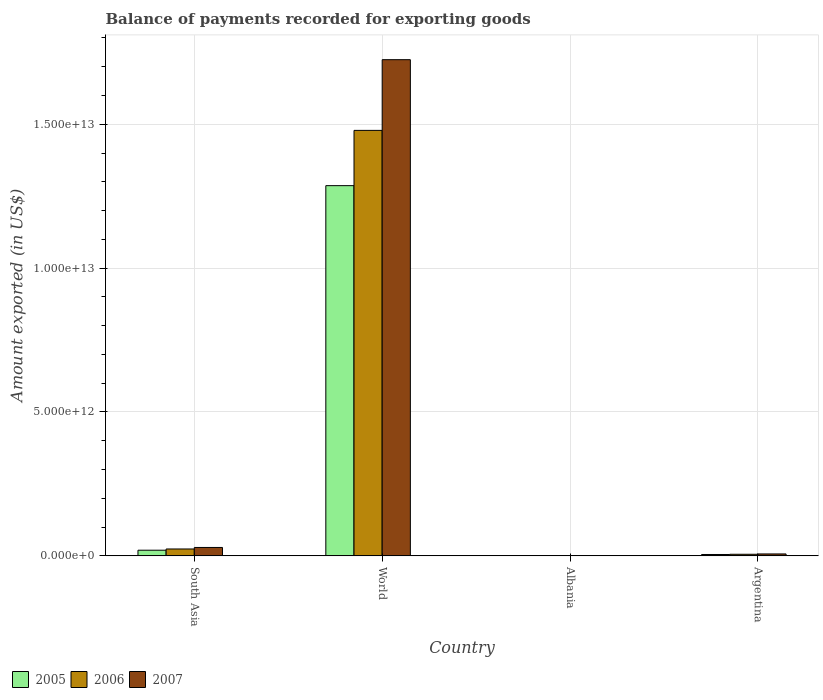How many bars are there on the 1st tick from the right?
Provide a short and direct response. 3. In how many cases, is the number of bars for a given country not equal to the number of legend labels?
Provide a succinct answer. 0. What is the amount exported in 2005 in South Asia?
Provide a short and direct response. 1.95e+11. Across all countries, what is the maximum amount exported in 2005?
Provide a short and direct response. 1.29e+13. Across all countries, what is the minimum amount exported in 2005?
Give a very brief answer. 1.46e+09. In which country was the amount exported in 2007 maximum?
Offer a very short reply. World. In which country was the amount exported in 2005 minimum?
Provide a succinct answer. Albania. What is the total amount exported in 2006 in the graph?
Your answer should be compact. 1.51e+13. What is the difference between the amount exported in 2006 in Argentina and that in South Asia?
Offer a terse response. -1.84e+11. What is the difference between the amount exported in 2007 in World and the amount exported in 2006 in Albania?
Make the answer very short. 1.72e+13. What is the average amount exported in 2007 per country?
Your answer should be compact. 4.40e+12. What is the difference between the amount exported of/in 2007 and amount exported of/in 2005 in World?
Offer a very short reply. 4.38e+12. In how many countries, is the amount exported in 2005 greater than 5000000000000 US$?
Keep it short and to the point. 1. What is the ratio of the amount exported in 2007 in South Asia to that in World?
Your answer should be very brief. 0.02. What is the difference between the highest and the second highest amount exported in 2006?
Offer a terse response. -1.47e+13. What is the difference between the highest and the lowest amount exported in 2006?
Provide a short and direct response. 1.48e+13. In how many countries, is the amount exported in 2006 greater than the average amount exported in 2006 taken over all countries?
Your answer should be compact. 1. What does the 1st bar from the right in South Asia represents?
Offer a very short reply. 2007. Is it the case that in every country, the sum of the amount exported in 2007 and amount exported in 2006 is greater than the amount exported in 2005?
Provide a short and direct response. Yes. How many bars are there?
Give a very brief answer. 12. What is the difference between two consecutive major ticks on the Y-axis?
Give a very brief answer. 5.00e+12. Are the values on the major ticks of Y-axis written in scientific E-notation?
Offer a terse response. Yes. Where does the legend appear in the graph?
Provide a short and direct response. Bottom left. How are the legend labels stacked?
Provide a short and direct response. Horizontal. What is the title of the graph?
Your answer should be very brief. Balance of payments recorded for exporting goods. Does "1964" appear as one of the legend labels in the graph?
Keep it short and to the point. No. What is the label or title of the X-axis?
Your answer should be compact. Country. What is the label or title of the Y-axis?
Ensure brevity in your answer.  Amount exported (in US$). What is the Amount exported (in US$) in 2005 in South Asia?
Your response must be concise. 1.95e+11. What is the Amount exported (in US$) in 2006 in South Asia?
Offer a terse response. 2.39e+11. What is the Amount exported (in US$) of 2007 in South Asia?
Offer a terse response. 2.91e+11. What is the Amount exported (in US$) in 2005 in World?
Keep it short and to the point. 1.29e+13. What is the Amount exported (in US$) of 2006 in World?
Provide a short and direct response. 1.48e+13. What is the Amount exported (in US$) in 2007 in World?
Your answer should be very brief. 1.72e+13. What is the Amount exported (in US$) in 2005 in Albania?
Offer a very short reply. 1.46e+09. What is the Amount exported (in US$) in 2006 in Albania?
Your answer should be compact. 1.87e+09. What is the Amount exported (in US$) in 2007 in Albania?
Make the answer very short. 2.46e+09. What is the Amount exported (in US$) in 2005 in Argentina?
Make the answer very short. 4.69e+1. What is the Amount exported (in US$) of 2006 in Argentina?
Keep it short and to the point. 5.44e+1. What is the Amount exported (in US$) in 2007 in Argentina?
Your answer should be very brief. 6.62e+1. Across all countries, what is the maximum Amount exported (in US$) of 2005?
Your answer should be very brief. 1.29e+13. Across all countries, what is the maximum Amount exported (in US$) of 2006?
Keep it short and to the point. 1.48e+13. Across all countries, what is the maximum Amount exported (in US$) of 2007?
Ensure brevity in your answer.  1.72e+13. Across all countries, what is the minimum Amount exported (in US$) in 2005?
Make the answer very short. 1.46e+09. Across all countries, what is the minimum Amount exported (in US$) of 2006?
Keep it short and to the point. 1.87e+09. Across all countries, what is the minimum Amount exported (in US$) of 2007?
Make the answer very short. 2.46e+09. What is the total Amount exported (in US$) of 2005 in the graph?
Your answer should be very brief. 1.31e+13. What is the total Amount exported (in US$) of 2006 in the graph?
Your answer should be compact. 1.51e+13. What is the total Amount exported (in US$) of 2007 in the graph?
Give a very brief answer. 1.76e+13. What is the difference between the Amount exported (in US$) in 2005 in South Asia and that in World?
Keep it short and to the point. -1.27e+13. What is the difference between the Amount exported (in US$) in 2006 in South Asia and that in World?
Provide a short and direct response. -1.46e+13. What is the difference between the Amount exported (in US$) in 2007 in South Asia and that in World?
Your answer should be very brief. -1.70e+13. What is the difference between the Amount exported (in US$) of 2005 in South Asia and that in Albania?
Provide a short and direct response. 1.94e+11. What is the difference between the Amount exported (in US$) in 2006 in South Asia and that in Albania?
Your answer should be compact. 2.37e+11. What is the difference between the Amount exported (in US$) of 2007 in South Asia and that in Albania?
Keep it short and to the point. 2.89e+11. What is the difference between the Amount exported (in US$) of 2005 in South Asia and that in Argentina?
Keep it short and to the point. 1.49e+11. What is the difference between the Amount exported (in US$) in 2006 in South Asia and that in Argentina?
Make the answer very short. 1.84e+11. What is the difference between the Amount exported (in US$) of 2007 in South Asia and that in Argentina?
Your response must be concise. 2.25e+11. What is the difference between the Amount exported (in US$) of 2005 in World and that in Albania?
Your answer should be compact. 1.29e+13. What is the difference between the Amount exported (in US$) in 2006 in World and that in Albania?
Provide a short and direct response. 1.48e+13. What is the difference between the Amount exported (in US$) of 2007 in World and that in Albania?
Give a very brief answer. 1.72e+13. What is the difference between the Amount exported (in US$) in 2005 in World and that in Argentina?
Offer a terse response. 1.28e+13. What is the difference between the Amount exported (in US$) in 2006 in World and that in Argentina?
Your answer should be very brief. 1.47e+13. What is the difference between the Amount exported (in US$) in 2007 in World and that in Argentina?
Give a very brief answer. 1.72e+13. What is the difference between the Amount exported (in US$) of 2005 in Albania and that in Argentina?
Keep it short and to the point. -4.54e+1. What is the difference between the Amount exported (in US$) of 2006 in Albania and that in Argentina?
Your answer should be compact. -5.26e+1. What is the difference between the Amount exported (in US$) in 2007 in Albania and that in Argentina?
Provide a succinct answer. -6.37e+1. What is the difference between the Amount exported (in US$) of 2005 in South Asia and the Amount exported (in US$) of 2006 in World?
Your response must be concise. -1.46e+13. What is the difference between the Amount exported (in US$) of 2005 in South Asia and the Amount exported (in US$) of 2007 in World?
Your response must be concise. -1.71e+13. What is the difference between the Amount exported (in US$) in 2006 in South Asia and the Amount exported (in US$) in 2007 in World?
Offer a very short reply. -1.70e+13. What is the difference between the Amount exported (in US$) in 2005 in South Asia and the Amount exported (in US$) in 2006 in Albania?
Your response must be concise. 1.94e+11. What is the difference between the Amount exported (in US$) in 2005 in South Asia and the Amount exported (in US$) in 2007 in Albania?
Keep it short and to the point. 1.93e+11. What is the difference between the Amount exported (in US$) in 2006 in South Asia and the Amount exported (in US$) in 2007 in Albania?
Your answer should be very brief. 2.36e+11. What is the difference between the Amount exported (in US$) of 2005 in South Asia and the Amount exported (in US$) of 2006 in Argentina?
Your answer should be very brief. 1.41e+11. What is the difference between the Amount exported (in US$) in 2005 in South Asia and the Amount exported (in US$) in 2007 in Argentina?
Make the answer very short. 1.29e+11. What is the difference between the Amount exported (in US$) of 2006 in South Asia and the Amount exported (in US$) of 2007 in Argentina?
Keep it short and to the point. 1.72e+11. What is the difference between the Amount exported (in US$) in 2005 in World and the Amount exported (in US$) in 2006 in Albania?
Offer a terse response. 1.29e+13. What is the difference between the Amount exported (in US$) of 2005 in World and the Amount exported (in US$) of 2007 in Albania?
Give a very brief answer. 1.29e+13. What is the difference between the Amount exported (in US$) of 2006 in World and the Amount exported (in US$) of 2007 in Albania?
Provide a succinct answer. 1.48e+13. What is the difference between the Amount exported (in US$) of 2005 in World and the Amount exported (in US$) of 2006 in Argentina?
Provide a short and direct response. 1.28e+13. What is the difference between the Amount exported (in US$) in 2005 in World and the Amount exported (in US$) in 2007 in Argentina?
Offer a terse response. 1.28e+13. What is the difference between the Amount exported (in US$) in 2006 in World and the Amount exported (in US$) in 2007 in Argentina?
Give a very brief answer. 1.47e+13. What is the difference between the Amount exported (in US$) in 2005 in Albania and the Amount exported (in US$) in 2006 in Argentina?
Your answer should be very brief. -5.30e+1. What is the difference between the Amount exported (in US$) of 2005 in Albania and the Amount exported (in US$) of 2007 in Argentina?
Ensure brevity in your answer.  -6.47e+1. What is the difference between the Amount exported (in US$) in 2006 in Albania and the Amount exported (in US$) in 2007 in Argentina?
Offer a terse response. -6.43e+1. What is the average Amount exported (in US$) in 2005 per country?
Ensure brevity in your answer.  3.28e+12. What is the average Amount exported (in US$) of 2006 per country?
Give a very brief answer. 3.77e+12. What is the average Amount exported (in US$) of 2007 per country?
Your answer should be compact. 4.40e+12. What is the difference between the Amount exported (in US$) of 2005 and Amount exported (in US$) of 2006 in South Asia?
Your answer should be very brief. -4.30e+1. What is the difference between the Amount exported (in US$) of 2005 and Amount exported (in US$) of 2007 in South Asia?
Ensure brevity in your answer.  -9.56e+1. What is the difference between the Amount exported (in US$) of 2006 and Amount exported (in US$) of 2007 in South Asia?
Your response must be concise. -5.26e+1. What is the difference between the Amount exported (in US$) in 2005 and Amount exported (in US$) in 2006 in World?
Provide a short and direct response. -1.92e+12. What is the difference between the Amount exported (in US$) in 2005 and Amount exported (in US$) in 2007 in World?
Offer a very short reply. -4.38e+12. What is the difference between the Amount exported (in US$) of 2006 and Amount exported (in US$) of 2007 in World?
Your answer should be compact. -2.46e+12. What is the difference between the Amount exported (in US$) of 2005 and Amount exported (in US$) of 2006 in Albania?
Provide a short and direct response. -4.09e+08. What is the difference between the Amount exported (in US$) in 2005 and Amount exported (in US$) in 2007 in Albania?
Your answer should be compact. -1.00e+09. What is the difference between the Amount exported (in US$) of 2006 and Amount exported (in US$) of 2007 in Albania?
Your answer should be very brief. -5.95e+08. What is the difference between the Amount exported (in US$) in 2005 and Amount exported (in US$) in 2006 in Argentina?
Provide a succinct answer. -7.54e+09. What is the difference between the Amount exported (in US$) in 2005 and Amount exported (in US$) in 2007 in Argentina?
Offer a terse response. -1.93e+1. What is the difference between the Amount exported (in US$) in 2006 and Amount exported (in US$) in 2007 in Argentina?
Provide a succinct answer. -1.17e+1. What is the ratio of the Amount exported (in US$) of 2005 in South Asia to that in World?
Give a very brief answer. 0.02. What is the ratio of the Amount exported (in US$) in 2006 in South Asia to that in World?
Provide a succinct answer. 0.02. What is the ratio of the Amount exported (in US$) in 2007 in South Asia to that in World?
Offer a very short reply. 0.02. What is the ratio of the Amount exported (in US$) in 2005 in South Asia to that in Albania?
Provide a succinct answer. 133.81. What is the ratio of the Amount exported (in US$) of 2006 in South Asia to that in Albania?
Make the answer very short. 127.58. What is the ratio of the Amount exported (in US$) in 2007 in South Asia to that in Albania?
Give a very brief answer. 118.12. What is the ratio of the Amount exported (in US$) of 2005 in South Asia to that in Argentina?
Your answer should be very brief. 4.17. What is the ratio of the Amount exported (in US$) of 2006 in South Asia to that in Argentina?
Your response must be concise. 4.38. What is the ratio of the Amount exported (in US$) of 2007 in South Asia to that in Argentina?
Keep it short and to the point. 4.4. What is the ratio of the Amount exported (in US$) of 2005 in World to that in Albania?
Keep it short and to the point. 8808.63. What is the ratio of the Amount exported (in US$) in 2006 in World to that in Albania?
Provide a short and direct response. 7910.28. What is the ratio of the Amount exported (in US$) in 2007 in World to that in Albania?
Keep it short and to the point. 6998.11. What is the ratio of the Amount exported (in US$) in 2005 in World to that in Argentina?
Provide a succinct answer. 274.4. What is the ratio of the Amount exported (in US$) of 2006 in World to that in Argentina?
Offer a very short reply. 271.7. What is the ratio of the Amount exported (in US$) in 2007 in World to that in Argentina?
Provide a short and direct response. 260.64. What is the ratio of the Amount exported (in US$) of 2005 in Albania to that in Argentina?
Your response must be concise. 0.03. What is the ratio of the Amount exported (in US$) in 2006 in Albania to that in Argentina?
Your answer should be very brief. 0.03. What is the ratio of the Amount exported (in US$) in 2007 in Albania to that in Argentina?
Offer a very short reply. 0.04. What is the difference between the highest and the second highest Amount exported (in US$) in 2005?
Keep it short and to the point. 1.27e+13. What is the difference between the highest and the second highest Amount exported (in US$) in 2006?
Make the answer very short. 1.46e+13. What is the difference between the highest and the second highest Amount exported (in US$) of 2007?
Ensure brevity in your answer.  1.70e+13. What is the difference between the highest and the lowest Amount exported (in US$) of 2005?
Your answer should be compact. 1.29e+13. What is the difference between the highest and the lowest Amount exported (in US$) in 2006?
Provide a succinct answer. 1.48e+13. What is the difference between the highest and the lowest Amount exported (in US$) of 2007?
Your answer should be very brief. 1.72e+13. 